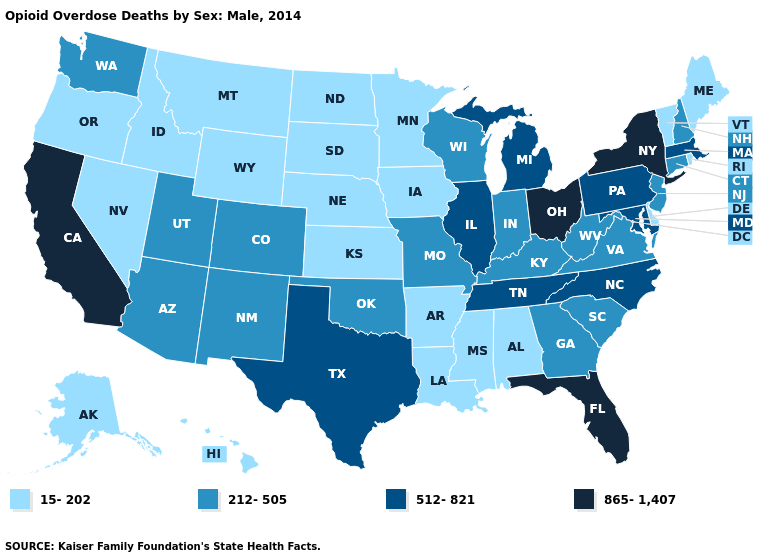What is the value of Kansas?
Be succinct. 15-202. Among the states that border Indiana , does Michigan have the lowest value?
Quick response, please. No. Name the states that have a value in the range 512-821?
Quick response, please. Illinois, Maryland, Massachusetts, Michigan, North Carolina, Pennsylvania, Tennessee, Texas. Does Maine have the lowest value in the USA?
Quick response, please. Yes. What is the value of Massachusetts?
Keep it brief. 512-821. Name the states that have a value in the range 512-821?
Answer briefly. Illinois, Maryland, Massachusetts, Michigan, North Carolina, Pennsylvania, Tennessee, Texas. Name the states that have a value in the range 512-821?
Short answer required. Illinois, Maryland, Massachusetts, Michigan, North Carolina, Pennsylvania, Tennessee, Texas. Which states hav the highest value in the Northeast?
Concise answer only. New York. What is the value of Nevada?
Short answer required. 15-202. Which states have the highest value in the USA?
Concise answer only. California, Florida, New York, Ohio. Among the states that border Minnesota , which have the highest value?
Give a very brief answer. Wisconsin. Which states have the lowest value in the South?
Keep it brief. Alabama, Arkansas, Delaware, Louisiana, Mississippi. Name the states that have a value in the range 512-821?
Keep it brief. Illinois, Maryland, Massachusetts, Michigan, North Carolina, Pennsylvania, Tennessee, Texas. What is the value of Pennsylvania?
Give a very brief answer. 512-821. 